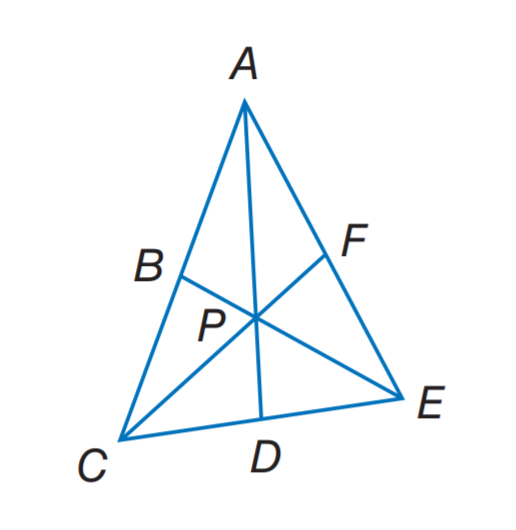Answer the mathemtical geometry problem and directly provide the correct option letter.
Question: In \triangle A C E, P is the centroid. P F = 6 and A D = 15. Find A P.
Choices: A: 6 B: 10 C: 12 D: 15 B 